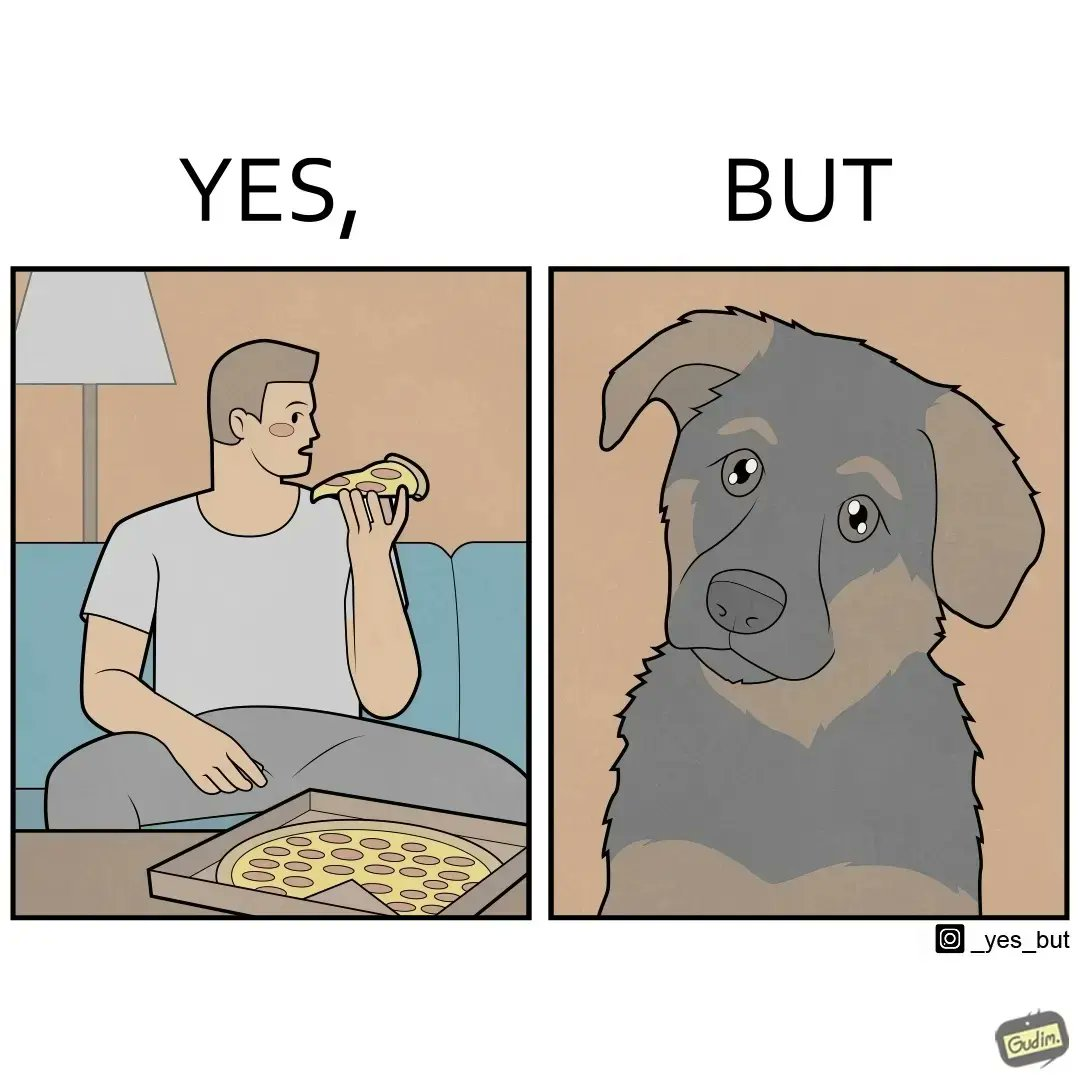Explain why this image is satirical. The images are funny since they show how pet owners cannot enjoy any tasty food like pizza without sharing with their pets. The look from the pets makes the owner too guilty if he does not share his food 